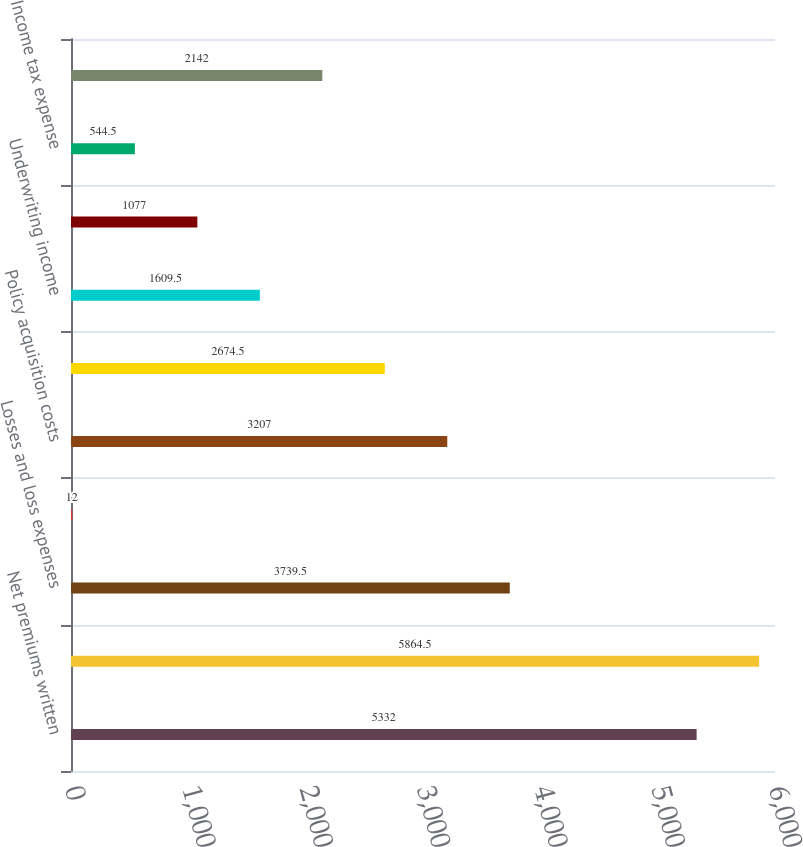<chart> <loc_0><loc_0><loc_500><loc_500><bar_chart><fcel>Net premiums written<fcel>Net premiums earned<fcel>Losses and loss expenses<fcel>Policy benefits<fcel>Policy acquisition costs<fcel>Administrative expenses<fcel>Underwriting income<fcel>Net investment income<fcel>Income tax expense<fcel>Net income<nl><fcel>5332<fcel>5864.5<fcel>3739.5<fcel>12<fcel>3207<fcel>2674.5<fcel>1609.5<fcel>1077<fcel>544.5<fcel>2142<nl></chart> 